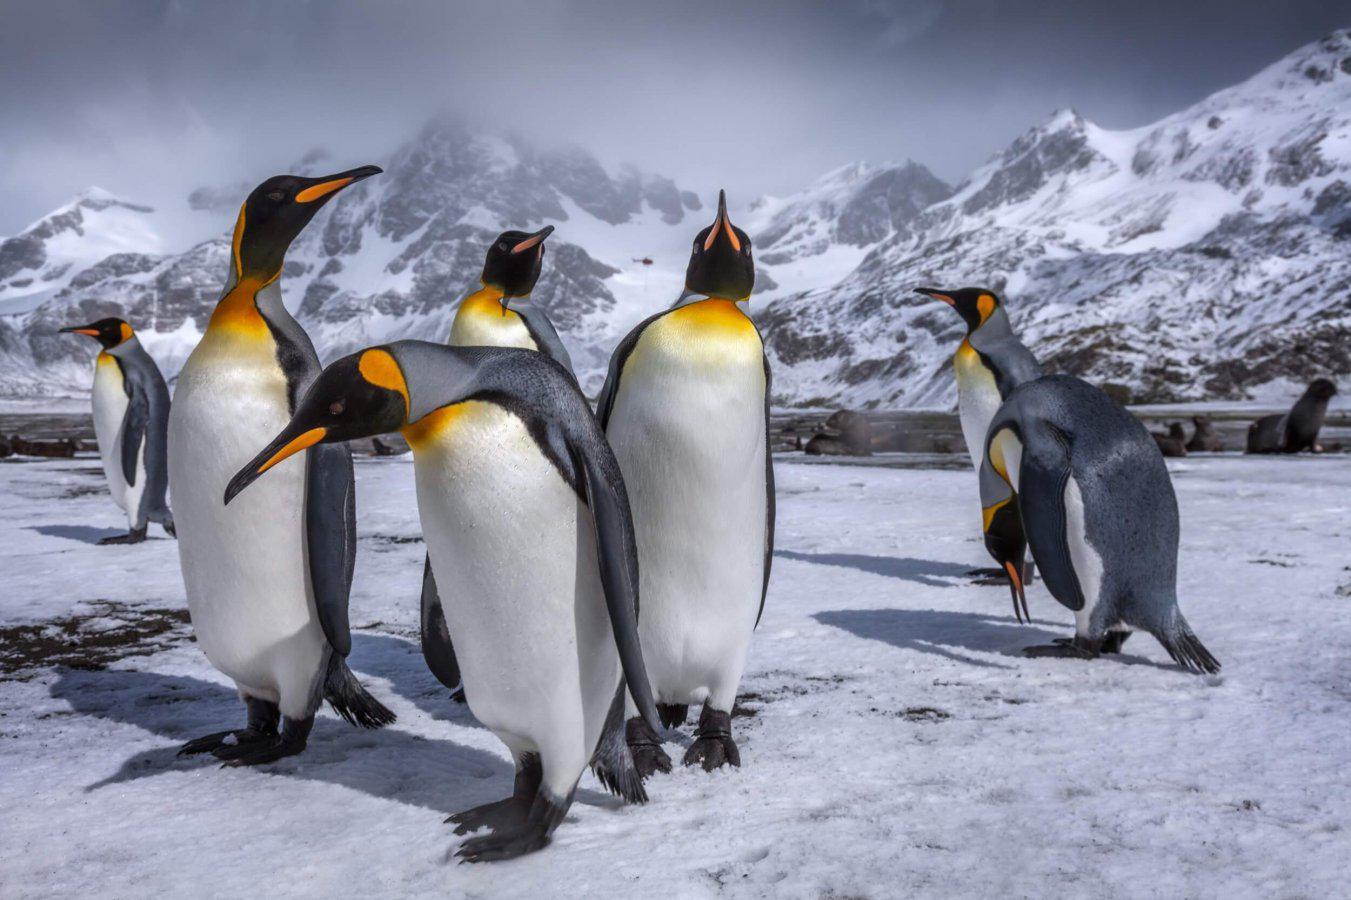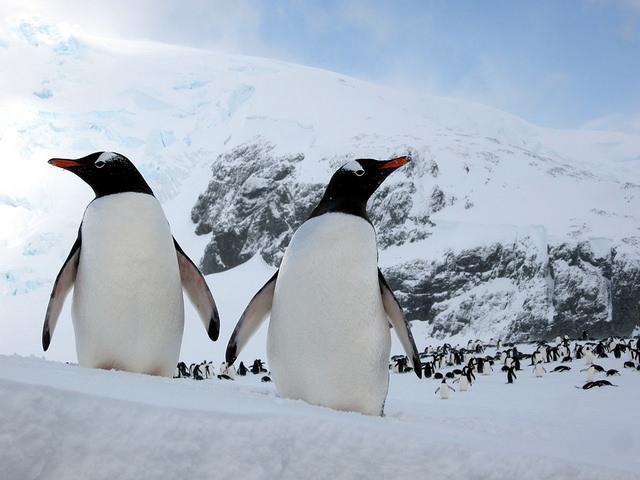The first image is the image on the left, the second image is the image on the right. Examine the images to the left and right. Is the description "One of the images features a penguin who is obviously young - still a chick!" accurate? Answer yes or no. No. 